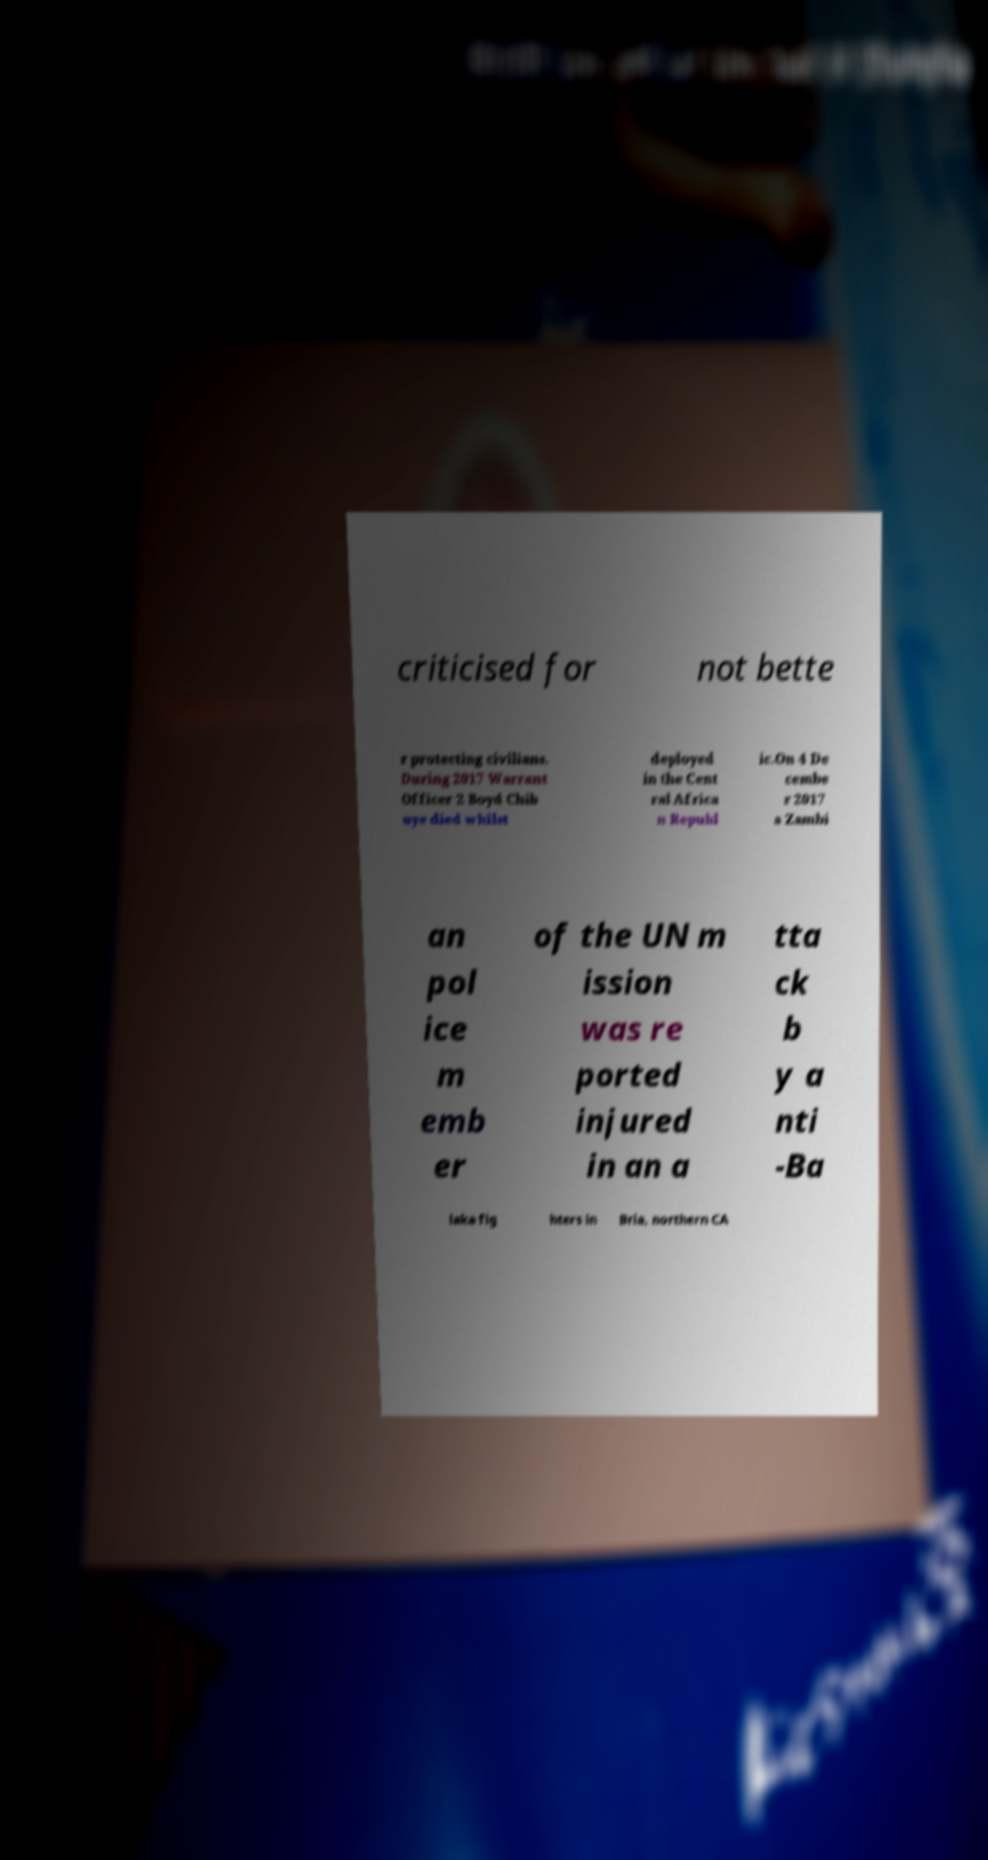Could you extract and type out the text from this image? criticised for not bette r protecting civilians. During 2017 Warrant Officer 2 Boyd Chib uye died whilst deployed in the Cent ral Africa n Republ ic.On 4 De cembe r 2017 a Zambi an pol ice m emb er of the UN m ission was re ported injured in an a tta ck b y a nti -Ba laka fig hters in Bria, northern CA 